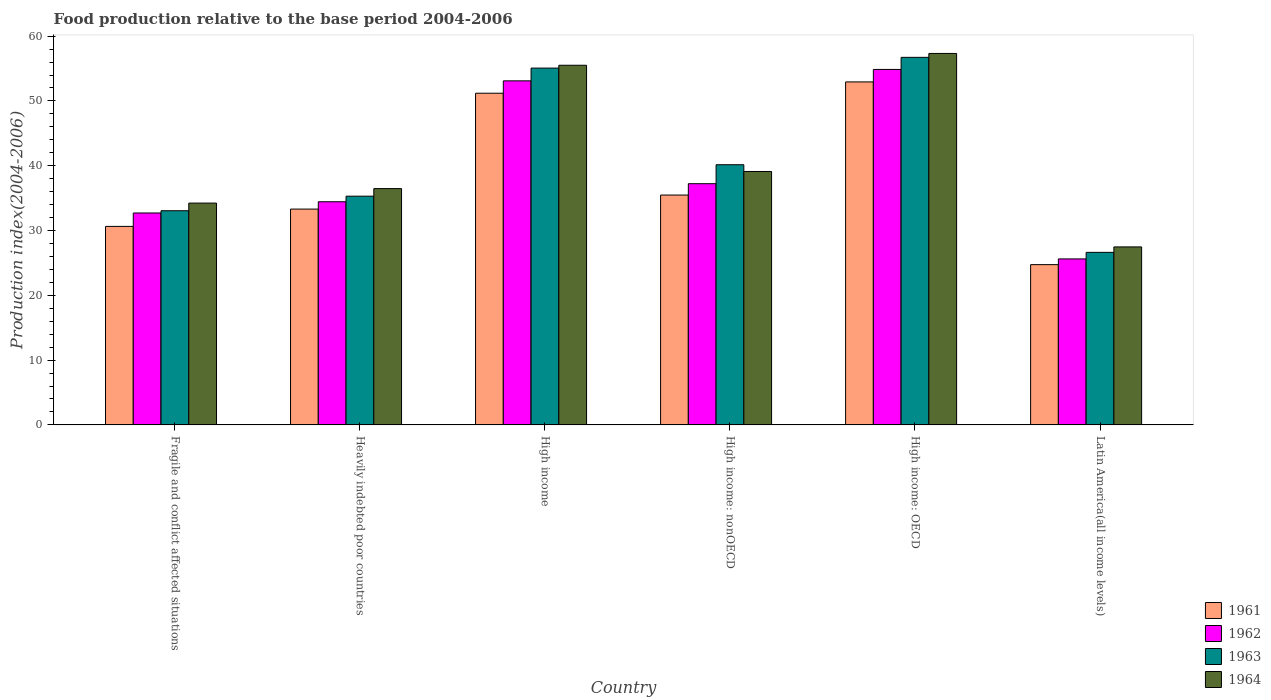How many different coloured bars are there?
Ensure brevity in your answer.  4. How many groups of bars are there?
Your response must be concise. 6. Are the number of bars per tick equal to the number of legend labels?
Provide a short and direct response. Yes. How many bars are there on the 4th tick from the left?
Your response must be concise. 4. What is the label of the 1st group of bars from the left?
Your answer should be very brief. Fragile and conflict affected situations. What is the food production index in 1961 in High income?
Your answer should be very brief. 51.19. Across all countries, what is the maximum food production index in 1961?
Provide a short and direct response. 52.93. Across all countries, what is the minimum food production index in 1963?
Make the answer very short. 26.63. In which country was the food production index in 1964 maximum?
Your answer should be compact. High income: OECD. In which country was the food production index in 1962 minimum?
Provide a short and direct response. Latin America(all income levels). What is the total food production index in 1964 in the graph?
Ensure brevity in your answer.  250.12. What is the difference between the food production index in 1964 in Heavily indebted poor countries and that in High income: nonOECD?
Your answer should be compact. -2.64. What is the difference between the food production index in 1962 in Latin America(all income levels) and the food production index in 1964 in High income?
Your response must be concise. -29.89. What is the average food production index in 1964 per country?
Keep it short and to the point. 41.69. What is the difference between the food production index of/in 1962 and food production index of/in 1963 in Heavily indebted poor countries?
Give a very brief answer. -0.86. What is the ratio of the food production index in 1964 in High income to that in High income: nonOECD?
Make the answer very short. 1.42. Is the food production index in 1961 in Heavily indebted poor countries less than that in Latin America(all income levels)?
Your answer should be compact. No. Is the difference between the food production index in 1962 in Fragile and conflict affected situations and Latin America(all income levels) greater than the difference between the food production index in 1963 in Fragile and conflict affected situations and Latin America(all income levels)?
Your response must be concise. Yes. What is the difference between the highest and the second highest food production index in 1963?
Give a very brief answer. 16.57. What is the difference between the highest and the lowest food production index in 1963?
Provide a succinct answer. 30.1. What does the 4th bar from the left in Latin America(all income levels) represents?
Offer a very short reply. 1964. What does the 3rd bar from the right in High income: nonOECD represents?
Your response must be concise. 1962. Is it the case that in every country, the sum of the food production index in 1962 and food production index in 1961 is greater than the food production index in 1964?
Your answer should be compact. Yes. How many bars are there?
Keep it short and to the point. 24. How many countries are there in the graph?
Provide a succinct answer. 6. Are the values on the major ticks of Y-axis written in scientific E-notation?
Make the answer very short. No. Does the graph contain any zero values?
Your answer should be very brief. No. Does the graph contain grids?
Provide a short and direct response. No. How many legend labels are there?
Provide a short and direct response. 4. What is the title of the graph?
Your answer should be compact. Food production relative to the base period 2004-2006. Does "1993" appear as one of the legend labels in the graph?
Your answer should be compact. No. What is the label or title of the X-axis?
Ensure brevity in your answer.  Country. What is the label or title of the Y-axis?
Offer a terse response. Production index(2004-2006). What is the Production index(2004-2006) in 1961 in Fragile and conflict affected situations?
Offer a terse response. 30.64. What is the Production index(2004-2006) of 1962 in Fragile and conflict affected situations?
Offer a terse response. 32.71. What is the Production index(2004-2006) in 1963 in Fragile and conflict affected situations?
Give a very brief answer. 33.05. What is the Production index(2004-2006) of 1964 in Fragile and conflict affected situations?
Make the answer very short. 34.23. What is the Production index(2004-2006) of 1961 in Heavily indebted poor countries?
Your answer should be very brief. 33.31. What is the Production index(2004-2006) of 1962 in Heavily indebted poor countries?
Provide a short and direct response. 34.44. What is the Production index(2004-2006) in 1963 in Heavily indebted poor countries?
Provide a succinct answer. 35.3. What is the Production index(2004-2006) of 1964 in Heavily indebted poor countries?
Your answer should be compact. 36.47. What is the Production index(2004-2006) of 1961 in High income?
Ensure brevity in your answer.  51.19. What is the Production index(2004-2006) of 1962 in High income?
Make the answer very short. 53.1. What is the Production index(2004-2006) in 1963 in High income?
Offer a terse response. 55.07. What is the Production index(2004-2006) of 1964 in High income?
Provide a short and direct response. 55.51. What is the Production index(2004-2006) of 1961 in High income: nonOECD?
Provide a short and direct response. 35.48. What is the Production index(2004-2006) in 1962 in High income: nonOECD?
Provide a succinct answer. 37.23. What is the Production index(2004-2006) of 1963 in High income: nonOECD?
Your answer should be compact. 40.16. What is the Production index(2004-2006) in 1964 in High income: nonOECD?
Give a very brief answer. 39.11. What is the Production index(2004-2006) of 1961 in High income: OECD?
Provide a short and direct response. 52.93. What is the Production index(2004-2006) in 1962 in High income: OECD?
Keep it short and to the point. 54.86. What is the Production index(2004-2006) of 1963 in High income: OECD?
Provide a succinct answer. 56.73. What is the Production index(2004-2006) of 1964 in High income: OECD?
Your answer should be very brief. 57.33. What is the Production index(2004-2006) in 1961 in Latin America(all income levels)?
Keep it short and to the point. 24.74. What is the Production index(2004-2006) in 1962 in Latin America(all income levels)?
Offer a terse response. 25.62. What is the Production index(2004-2006) of 1963 in Latin America(all income levels)?
Make the answer very short. 26.63. What is the Production index(2004-2006) of 1964 in Latin America(all income levels)?
Provide a succinct answer. 27.47. Across all countries, what is the maximum Production index(2004-2006) in 1961?
Your response must be concise. 52.93. Across all countries, what is the maximum Production index(2004-2006) of 1962?
Make the answer very short. 54.86. Across all countries, what is the maximum Production index(2004-2006) of 1963?
Give a very brief answer. 56.73. Across all countries, what is the maximum Production index(2004-2006) in 1964?
Offer a terse response. 57.33. Across all countries, what is the minimum Production index(2004-2006) in 1961?
Provide a succinct answer. 24.74. Across all countries, what is the minimum Production index(2004-2006) in 1962?
Your answer should be very brief. 25.62. Across all countries, what is the minimum Production index(2004-2006) in 1963?
Your answer should be compact. 26.63. Across all countries, what is the minimum Production index(2004-2006) of 1964?
Provide a succinct answer. 27.47. What is the total Production index(2004-2006) of 1961 in the graph?
Offer a very short reply. 228.28. What is the total Production index(2004-2006) of 1962 in the graph?
Offer a very short reply. 237.96. What is the total Production index(2004-2006) in 1963 in the graph?
Your answer should be very brief. 246.93. What is the total Production index(2004-2006) in 1964 in the graph?
Ensure brevity in your answer.  250.12. What is the difference between the Production index(2004-2006) of 1961 in Fragile and conflict affected situations and that in Heavily indebted poor countries?
Your answer should be very brief. -2.67. What is the difference between the Production index(2004-2006) in 1962 in Fragile and conflict affected situations and that in Heavily indebted poor countries?
Make the answer very short. -1.74. What is the difference between the Production index(2004-2006) in 1963 in Fragile and conflict affected situations and that in Heavily indebted poor countries?
Keep it short and to the point. -2.25. What is the difference between the Production index(2004-2006) in 1964 in Fragile and conflict affected situations and that in Heavily indebted poor countries?
Your answer should be compact. -2.24. What is the difference between the Production index(2004-2006) in 1961 in Fragile and conflict affected situations and that in High income?
Give a very brief answer. -20.55. What is the difference between the Production index(2004-2006) in 1962 in Fragile and conflict affected situations and that in High income?
Keep it short and to the point. -20.39. What is the difference between the Production index(2004-2006) of 1963 in Fragile and conflict affected situations and that in High income?
Keep it short and to the point. -22.02. What is the difference between the Production index(2004-2006) in 1964 in Fragile and conflict affected situations and that in High income?
Your answer should be very brief. -21.27. What is the difference between the Production index(2004-2006) of 1961 in Fragile and conflict affected situations and that in High income: nonOECD?
Provide a succinct answer. -4.84. What is the difference between the Production index(2004-2006) in 1962 in Fragile and conflict affected situations and that in High income: nonOECD?
Keep it short and to the point. -4.52. What is the difference between the Production index(2004-2006) in 1963 in Fragile and conflict affected situations and that in High income: nonOECD?
Provide a short and direct response. -7.1. What is the difference between the Production index(2004-2006) of 1964 in Fragile and conflict affected situations and that in High income: nonOECD?
Offer a very short reply. -4.88. What is the difference between the Production index(2004-2006) of 1961 in Fragile and conflict affected situations and that in High income: OECD?
Your response must be concise. -22.3. What is the difference between the Production index(2004-2006) in 1962 in Fragile and conflict affected situations and that in High income: OECD?
Provide a succinct answer. -22.16. What is the difference between the Production index(2004-2006) of 1963 in Fragile and conflict affected situations and that in High income: OECD?
Make the answer very short. -23.67. What is the difference between the Production index(2004-2006) of 1964 in Fragile and conflict affected situations and that in High income: OECD?
Offer a very short reply. -23.09. What is the difference between the Production index(2004-2006) of 1961 in Fragile and conflict affected situations and that in Latin America(all income levels)?
Your response must be concise. 5.9. What is the difference between the Production index(2004-2006) in 1962 in Fragile and conflict affected situations and that in Latin America(all income levels)?
Your answer should be compact. 7.09. What is the difference between the Production index(2004-2006) in 1963 in Fragile and conflict affected situations and that in Latin America(all income levels)?
Make the answer very short. 6.42. What is the difference between the Production index(2004-2006) in 1964 in Fragile and conflict affected situations and that in Latin America(all income levels)?
Provide a short and direct response. 6.76. What is the difference between the Production index(2004-2006) in 1961 in Heavily indebted poor countries and that in High income?
Offer a terse response. -17.88. What is the difference between the Production index(2004-2006) in 1962 in Heavily indebted poor countries and that in High income?
Ensure brevity in your answer.  -18.66. What is the difference between the Production index(2004-2006) of 1963 in Heavily indebted poor countries and that in High income?
Provide a short and direct response. -19.77. What is the difference between the Production index(2004-2006) of 1964 in Heavily indebted poor countries and that in High income?
Your answer should be compact. -19.04. What is the difference between the Production index(2004-2006) in 1961 in Heavily indebted poor countries and that in High income: nonOECD?
Your response must be concise. -2.17. What is the difference between the Production index(2004-2006) of 1962 in Heavily indebted poor countries and that in High income: nonOECD?
Keep it short and to the point. -2.78. What is the difference between the Production index(2004-2006) in 1963 in Heavily indebted poor countries and that in High income: nonOECD?
Your answer should be compact. -4.86. What is the difference between the Production index(2004-2006) of 1964 in Heavily indebted poor countries and that in High income: nonOECD?
Make the answer very short. -2.64. What is the difference between the Production index(2004-2006) of 1961 in Heavily indebted poor countries and that in High income: OECD?
Your response must be concise. -19.63. What is the difference between the Production index(2004-2006) of 1962 in Heavily indebted poor countries and that in High income: OECD?
Your answer should be very brief. -20.42. What is the difference between the Production index(2004-2006) in 1963 in Heavily indebted poor countries and that in High income: OECD?
Your response must be concise. -21.43. What is the difference between the Production index(2004-2006) of 1964 in Heavily indebted poor countries and that in High income: OECD?
Offer a very short reply. -20.86. What is the difference between the Production index(2004-2006) in 1961 in Heavily indebted poor countries and that in Latin America(all income levels)?
Make the answer very short. 8.57. What is the difference between the Production index(2004-2006) in 1962 in Heavily indebted poor countries and that in Latin America(all income levels)?
Offer a terse response. 8.82. What is the difference between the Production index(2004-2006) of 1963 in Heavily indebted poor countries and that in Latin America(all income levels)?
Provide a short and direct response. 8.67. What is the difference between the Production index(2004-2006) of 1964 in Heavily indebted poor countries and that in Latin America(all income levels)?
Your answer should be very brief. 9. What is the difference between the Production index(2004-2006) of 1961 in High income and that in High income: nonOECD?
Your response must be concise. 15.71. What is the difference between the Production index(2004-2006) in 1962 in High income and that in High income: nonOECD?
Keep it short and to the point. 15.87. What is the difference between the Production index(2004-2006) in 1963 in High income and that in High income: nonOECD?
Make the answer very short. 14.91. What is the difference between the Production index(2004-2006) in 1964 in High income and that in High income: nonOECD?
Provide a short and direct response. 16.39. What is the difference between the Production index(2004-2006) in 1961 in High income and that in High income: OECD?
Make the answer very short. -1.75. What is the difference between the Production index(2004-2006) in 1962 in High income and that in High income: OECD?
Ensure brevity in your answer.  -1.76. What is the difference between the Production index(2004-2006) in 1963 in High income and that in High income: OECD?
Provide a short and direct response. -1.66. What is the difference between the Production index(2004-2006) in 1964 in High income and that in High income: OECD?
Your answer should be very brief. -1.82. What is the difference between the Production index(2004-2006) in 1961 in High income and that in Latin America(all income levels)?
Offer a very short reply. 26.45. What is the difference between the Production index(2004-2006) in 1962 in High income and that in Latin America(all income levels)?
Your answer should be very brief. 27.48. What is the difference between the Production index(2004-2006) of 1963 in High income and that in Latin America(all income levels)?
Provide a succinct answer. 28.44. What is the difference between the Production index(2004-2006) of 1964 in High income and that in Latin America(all income levels)?
Your answer should be very brief. 28.04. What is the difference between the Production index(2004-2006) of 1961 in High income: nonOECD and that in High income: OECD?
Give a very brief answer. -17.46. What is the difference between the Production index(2004-2006) of 1962 in High income: nonOECD and that in High income: OECD?
Offer a terse response. -17.64. What is the difference between the Production index(2004-2006) in 1963 in High income: nonOECD and that in High income: OECD?
Offer a very short reply. -16.57. What is the difference between the Production index(2004-2006) of 1964 in High income: nonOECD and that in High income: OECD?
Offer a very short reply. -18.22. What is the difference between the Production index(2004-2006) of 1961 in High income: nonOECD and that in Latin America(all income levels)?
Keep it short and to the point. 10.74. What is the difference between the Production index(2004-2006) in 1962 in High income: nonOECD and that in Latin America(all income levels)?
Provide a succinct answer. 11.61. What is the difference between the Production index(2004-2006) in 1963 in High income: nonOECD and that in Latin America(all income levels)?
Your response must be concise. 13.53. What is the difference between the Production index(2004-2006) of 1964 in High income: nonOECD and that in Latin America(all income levels)?
Make the answer very short. 11.64. What is the difference between the Production index(2004-2006) of 1961 in High income: OECD and that in Latin America(all income levels)?
Your response must be concise. 28.2. What is the difference between the Production index(2004-2006) of 1962 in High income: OECD and that in Latin America(all income levels)?
Ensure brevity in your answer.  29.24. What is the difference between the Production index(2004-2006) of 1963 in High income: OECD and that in Latin America(all income levels)?
Your answer should be very brief. 30.1. What is the difference between the Production index(2004-2006) of 1964 in High income: OECD and that in Latin America(all income levels)?
Provide a succinct answer. 29.86. What is the difference between the Production index(2004-2006) of 1961 in Fragile and conflict affected situations and the Production index(2004-2006) of 1962 in Heavily indebted poor countries?
Your answer should be very brief. -3.81. What is the difference between the Production index(2004-2006) of 1961 in Fragile and conflict affected situations and the Production index(2004-2006) of 1963 in Heavily indebted poor countries?
Make the answer very short. -4.66. What is the difference between the Production index(2004-2006) in 1961 in Fragile and conflict affected situations and the Production index(2004-2006) in 1964 in Heavily indebted poor countries?
Offer a very short reply. -5.83. What is the difference between the Production index(2004-2006) of 1962 in Fragile and conflict affected situations and the Production index(2004-2006) of 1963 in Heavily indebted poor countries?
Offer a very short reply. -2.59. What is the difference between the Production index(2004-2006) in 1962 in Fragile and conflict affected situations and the Production index(2004-2006) in 1964 in Heavily indebted poor countries?
Your response must be concise. -3.76. What is the difference between the Production index(2004-2006) of 1963 in Fragile and conflict affected situations and the Production index(2004-2006) of 1964 in Heavily indebted poor countries?
Give a very brief answer. -3.42. What is the difference between the Production index(2004-2006) of 1961 in Fragile and conflict affected situations and the Production index(2004-2006) of 1962 in High income?
Provide a short and direct response. -22.46. What is the difference between the Production index(2004-2006) of 1961 in Fragile and conflict affected situations and the Production index(2004-2006) of 1963 in High income?
Ensure brevity in your answer.  -24.43. What is the difference between the Production index(2004-2006) in 1961 in Fragile and conflict affected situations and the Production index(2004-2006) in 1964 in High income?
Your answer should be compact. -24.87. What is the difference between the Production index(2004-2006) in 1962 in Fragile and conflict affected situations and the Production index(2004-2006) in 1963 in High income?
Ensure brevity in your answer.  -22.36. What is the difference between the Production index(2004-2006) in 1962 in Fragile and conflict affected situations and the Production index(2004-2006) in 1964 in High income?
Your answer should be very brief. -22.8. What is the difference between the Production index(2004-2006) of 1963 in Fragile and conflict affected situations and the Production index(2004-2006) of 1964 in High income?
Provide a short and direct response. -22.45. What is the difference between the Production index(2004-2006) of 1961 in Fragile and conflict affected situations and the Production index(2004-2006) of 1962 in High income: nonOECD?
Ensure brevity in your answer.  -6.59. What is the difference between the Production index(2004-2006) in 1961 in Fragile and conflict affected situations and the Production index(2004-2006) in 1963 in High income: nonOECD?
Provide a short and direct response. -9.52. What is the difference between the Production index(2004-2006) in 1961 in Fragile and conflict affected situations and the Production index(2004-2006) in 1964 in High income: nonOECD?
Offer a very short reply. -8.47. What is the difference between the Production index(2004-2006) of 1962 in Fragile and conflict affected situations and the Production index(2004-2006) of 1963 in High income: nonOECD?
Provide a short and direct response. -7.45. What is the difference between the Production index(2004-2006) of 1962 in Fragile and conflict affected situations and the Production index(2004-2006) of 1964 in High income: nonOECD?
Offer a terse response. -6.4. What is the difference between the Production index(2004-2006) of 1963 in Fragile and conflict affected situations and the Production index(2004-2006) of 1964 in High income: nonOECD?
Offer a terse response. -6.06. What is the difference between the Production index(2004-2006) in 1961 in Fragile and conflict affected situations and the Production index(2004-2006) in 1962 in High income: OECD?
Your answer should be compact. -24.23. What is the difference between the Production index(2004-2006) in 1961 in Fragile and conflict affected situations and the Production index(2004-2006) in 1963 in High income: OECD?
Make the answer very short. -26.09. What is the difference between the Production index(2004-2006) in 1961 in Fragile and conflict affected situations and the Production index(2004-2006) in 1964 in High income: OECD?
Your response must be concise. -26.69. What is the difference between the Production index(2004-2006) in 1962 in Fragile and conflict affected situations and the Production index(2004-2006) in 1963 in High income: OECD?
Your answer should be very brief. -24.02. What is the difference between the Production index(2004-2006) in 1962 in Fragile and conflict affected situations and the Production index(2004-2006) in 1964 in High income: OECD?
Provide a short and direct response. -24.62. What is the difference between the Production index(2004-2006) in 1963 in Fragile and conflict affected situations and the Production index(2004-2006) in 1964 in High income: OECD?
Ensure brevity in your answer.  -24.28. What is the difference between the Production index(2004-2006) of 1961 in Fragile and conflict affected situations and the Production index(2004-2006) of 1962 in Latin America(all income levels)?
Ensure brevity in your answer.  5.02. What is the difference between the Production index(2004-2006) in 1961 in Fragile and conflict affected situations and the Production index(2004-2006) in 1963 in Latin America(all income levels)?
Keep it short and to the point. 4.01. What is the difference between the Production index(2004-2006) of 1961 in Fragile and conflict affected situations and the Production index(2004-2006) of 1964 in Latin America(all income levels)?
Keep it short and to the point. 3.17. What is the difference between the Production index(2004-2006) in 1962 in Fragile and conflict affected situations and the Production index(2004-2006) in 1963 in Latin America(all income levels)?
Your answer should be very brief. 6.08. What is the difference between the Production index(2004-2006) in 1962 in Fragile and conflict affected situations and the Production index(2004-2006) in 1964 in Latin America(all income levels)?
Offer a very short reply. 5.24. What is the difference between the Production index(2004-2006) of 1963 in Fragile and conflict affected situations and the Production index(2004-2006) of 1964 in Latin America(all income levels)?
Provide a succinct answer. 5.58. What is the difference between the Production index(2004-2006) of 1961 in Heavily indebted poor countries and the Production index(2004-2006) of 1962 in High income?
Offer a very short reply. -19.79. What is the difference between the Production index(2004-2006) in 1961 in Heavily indebted poor countries and the Production index(2004-2006) in 1963 in High income?
Provide a short and direct response. -21.76. What is the difference between the Production index(2004-2006) in 1961 in Heavily indebted poor countries and the Production index(2004-2006) in 1964 in High income?
Your answer should be very brief. -22.2. What is the difference between the Production index(2004-2006) in 1962 in Heavily indebted poor countries and the Production index(2004-2006) in 1963 in High income?
Your response must be concise. -20.62. What is the difference between the Production index(2004-2006) of 1962 in Heavily indebted poor countries and the Production index(2004-2006) of 1964 in High income?
Provide a short and direct response. -21.06. What is the difference between the Production index(2004-2006) of 1963 in Heavily indebted poor countries and the Production index(2004-2006) of 1964 in High income?
Ensure brevity in your answer.  -20.21. What is the difference between the Production index(2004-2006) of 1961 in Heavily indebted poor countries and the Production index(2004-2006) of 1962 in High income: nonOECD?
Provide a short and direct response. -3.92. What is the difference between the Production index(2004-2006) in 1961 in Heavily indebted poor countries and the Production index(2004-2006) in 1963 in High income: nonOECD?
Offer a terse response. -6.85. What is the difference between the Production index(2004-2006) in 1961 in Heavily indebted poor countries and the Production index(2004-2006) in 1964 in High income: nonOECD?
Offer a very short reply. -5.8. What is the difference between the Production index(2004-2006) of 1962 in Heavily indebted poor countries and the Production index(2004-2006) of 1963 in High income: nonOECD?
Provide a succinct answer. -5.71. What is the difference between the Production index(2004-2006) of 1962 in Heavily indebted poor countries and the Production index(2004-2006) of 1964 in High income: nonOECD?
Offer a terse response. -4.67. What is the difference between the Production index(2004-2006) in 1963 in Heavily indebted poor countries and the Production index(2004-2006) in 1964 in High income: nonOECD?
Provide a succinct answer. -3.81. What is the difference between the Production index(2004-2006) of 1961 in Heavily indebted poor countries and the Production index(2004-2006) of 1962 in High income: OECD?
Offer a very short reply. -21.56. What is the difference between the Production index(2004-2006) in 1961 in Heavily indebted poor countries and the Production index(2004-2006) in 1963 in High income: OECD?
Your answer should be very brief. -23.42. What is the difference between the Production index(2004-2006) in 1961 in Heavily indebted poor countries and the Production index(2004-2006) in 1964 in High income: OECD?
Ensure brevity in your answer.  -24.02. What is the difference between the Production index(2004-2006) of 1962 in Heavily indebted poor countries and the Production index(2004-2006) of 1963 in High income: OECD?
Offer a very short reply. -22.28. What is the difference between the Production index(2004-2006) of 1962 in Heavily indebted poor countries and the Production index(2004-2006) of 1964 in High income: OECD?
Offer a terse response. -22.89. What is the difference between the Production index(2004-2006) in 1963 in Heavily indebted poor countries and the Production index(2004-2006) in 1964 in High income: OECD?
Keep it short and to the point. -22.03. What is the difference between the Production index(2004-2006) in 1961 in Heavily indebted poor countries and the Production index(2004-2006) in 1962 in Latin America(all income levels)?
Provide a short and direct response. 7.69. What is the difference between the Production index(2004-2006) in 1961 in Heavily indebted poor countries and the Production index(2004-2006) in 1963 in Latin America(all income levels)?
Make the answer very short. 6.68. What is the difference between the Production index(2004-2006) in 1961 in Heavily indebted poor countries and the Production index(2004-2006) in 1964 in Latin America(all income levels)?
Ensure brevity in your answer.  5.84. What is the difference between the Production index(2004-2006) of 1962 in Heavily indebted poor countries and the Production index(2004-2006) of 1963 in Latin America(all income levels)?
Keep it short and to the point. 7.81. What is the difference between the Production index(2004-2006) of 1962 in Heavily indebted poor countries and the Production index(2004-2006) of 1964 in Latin America(all income levels)?
Keep it short and to the point. 6.97. What is the difference between the Production index(2004-2006) in 1963 in Heavily indebted poor countries and the Production index(2004-2006) in 1964 in Latin America(all income levels)?
Keep it short and to the point. 7.83. What is the difference between the Production index(2004-2006) in 1961 in High income and the Production index(2004-2006) in 1962 in High income: nonOECD?
Provide a short and direct response. 13.96. What is the difference between the Production index(2004-2006) in 1961 in High income and the Production index(2004-2006) in 1963 in High income: nonOECD?
Provide a short and direct response. 11.03. What is the difference between the Production index(2004-2006) of 1961 in High income and the Production index(2004-2006) of 1964 in High income: nonOECD?
Give a very brief answer. 12.08. What is the difference between the Production index(2004-2006) of 1962 in High income and the Production index(2004-2006) of 1963 in High income: nonOECD?
Provide a succinct answer. 12.94. What is the difference between the Production index(2004-2006) of 1962 in High income and the Production index(2004-2006) of 1964 in High income: nonOECD?
Provide a succinct answer. 13.99. What is the difference between the Production index(2004-2006) in 1963 in High income and the Production index(2004-2006) in 1964 in High income: nonOECD?
Make the answer very short. 15.96. What is the difference between the Production index(2004-2006) of 1961 in High income and the Production index(2004-2006) of 1962 in High income: OECD?
Make the answer very short. -3.67. What is the difference between the Production index(2004-2006) in 1961 in High income and the Production index(2004-2006) in 1963 in High income: OECD?
Give a very brief answer. -5.54. What is the difference between the Production index(2004-2006) in 1961 in High income and the Production index(2004-2006) in 1964 in High income: OECD?
Your answer should be compact. -6.14. What is the difference between the Production index(2004-2006) in 1962 in High income and the Production index(2004-2006) in 1963 in High income: OECD?
Keep it short and to the point. -3.63. What is the difference between the Production index(2004-2006) of 1962 in High income and the Production index(2004-2006) of 1964 in High income: OECD?
Keep it short and to the point. -4.23. What is the difference between the Production index(2004-2006) in 1963 in High income and the Production index(2004-2006) in 1964 in High income: OECD?
Ensure brevity in your answer.  -2.26. What is the difference between the Production index(2004-2006) of 1961 in High income and the Production index(2004-2006) of 1962 in Latin America(all income levels)?
Ensure brevity in your answer.  25.57. What is the difference between the Production index(2004-2006) in 1961 in High income and the Production index(2004-2006) in 1963 in Latin America(all income levels)?
Offer a very short reply. 24.56. What is the difference between the Production index(2004-2006) of 1961 in High income and the Production index(2004-2006) of 1964 in Latin America(all income levels)?
Offer a terse response. 23.72. What is the difference between the Production index(2004-2006) in 1962 in High income and the Production index(2004-2006) in 1963 in Latin America(all income levels)?
Your answer should be very brief. 26.47. What is the difference between the Production index(2004-2006) in 1962 in High income and the Production index(2004-2006) in 1964 in Latin America(all income levels)?
Give a very brief answer. 25.63. What is the difference between the Production index(2004-2006) in 1963 in High income and the Production index(2004-2006) in 1964 in Latin America(all income levels)?
Provide a short and direct response. 27.6. What is the difference between the Production index(2004-2006) in 1961 in High income: nonOECD and the Production index(2004-2006) in 1962 in High income: OECD?
Make the answer very short. -19.39. What is the difference between the Production index(2004-2006) of 1961 in High income: nonOECD and the Production index(2004-2006) of 1963 in High income: OECD?
Offer a very short reply. -21.25. What is the difference between the Production index(2004-2006) in 1961 in High income: nonOECD and the Production index(2004-2006) in 1964 in High income: OECD?
Offer a very short reply. -21.85. What is the difference between the Production index(2004-2006) in 1962 in High income: nonOECD and the Production index(2004-2006) in 1963 in High income: OECD?
Your response must be concise. -19.5. What is the difference between the Production index(2004-2006) of 1962 in High income: nonOECD and the Production index(2004-2006) of 1964 in High income: OECD?
Your answer should be compact. -20.1. What is the difference between the Production index(2004-2006) in 1963 in High income: nonOECD and the Production index(2004-2006) in 1964 in High income: OECD?
Provide a short and direct response. -17.17. What is the difference between the Production index(2004-2006) in 1961 in High income: nonOECD and the Production index(2004-2006) in 1962 in Latin America(all income levels)?
Provide a short and direct response. 9.86. What is the difference between the Production index(2004-2006) of 1961 in High income: nonOECD and the Production index(2004-2006) of 1963 in Latin America(all income levels)?
Ensure brevity in your answer.  8.85. What is the difference between the Production index(2004-2006) of 1961 in High income: nonOECD and the Production index(2004-2006) of 1964 in Latin America(all income levels)?
Your response must be concise. 8. What is the difference between the Production index(2004-2006) in 1962 in High income: nonOECD and the Production index(2004-2006) in 1963 in Latin America(all income levels)?
Your answer should be compact. 10.6. What is the difference between the Production index(2004-2006) of 1962 in High income: nonOECD and the Production index(2004-2006) of 1964 in Latin America(all income levels)?
Provide a succinct answer. 9.76. What is the difference between the Production index(2004-2006) in 1963 in High income: nonOECD and the Production index(2004-2006) in 1964 in Latin America(all income levels)?
Offer a terse response. 12.68. What is the difference between the Production index(2004-2006) of 1961 in High income: OECD and the Production index(2004-2006) of 1962 in Latin America(all income levels)?
Ensure brevity in your answer.  27.31. What is the difference between the Production index(2004-2006) in 1961 in High income: OECD and the Production index(2004-2006) in 1963 in Latin America(all income levels)?
Ensure brevity in your answer.  26.3. What is the difference between the Production index(2004-2006) in 1961 in High income: OECD and the Production index(2004-2006) in 1964 in Latin America(all income levels)?
Keep it short and to the point. 25.46. What is the difference between the Production index(2004-2006) of 1962 in High income: OECD and the Production index(2004-2006) of 1963 in Latin America(all income levels)?
Make the answer very short. 28.23. What is the difference between the Production index(2004-2006) of 1962 in High income: OECD and the Production index(2004-2006) of 1964 in Latin America(all income levels)?
Offer a very short reply. 27.39. What is the difference between the Production index(2004-2006) in 1963 in High income: OECD and the Production index(2004-2006) in 1964 in Latin America(all income levels)?
Provide a short and direct response. 29.25. What is the average Production index(2004-2006) in 1961 per country?
Provide a short and direct response. 38.05. What is the average Production index(2004-2006) in 1962 per country?
Ensure brevity in your answer.  39.66. What is the average Production index(2004-2006) in 1963 per country?
Offer a very short reply. 41.16. What is the average Production index(2004-2006) in 1964 per country?
Your answer should be compact. 41.69. What is the difference between the Production index(2004-2006) of 1961 and Production index(2004-2006) of 1962 in Fragile and conflict affected situations?
Provide a succinct answer. -2.07. What is the difference between the Production index(2004-2006) of 1961 and Production index(2004-2006) of 1963 in Fragile and conflict affected situations?
Provide a succinct answer. -2.42. What is the difference between the Production index(2004-2006) in 1961 and Production index(2004-2006) in 1964 in Fragile and conflict affected situations?
Give a very brief answer. -3.6. What is the difference between the Production index(2004-2006) of 1962 and Production index(2004-2006) of 1963 in Fragile and conflict affected situations?
Provide a succinct answer. -0.35. What is the difference between the Production index(2004-2006) in 1962 and Production index(2004-2006) in 1964 in Fragile and conflict affected situations?
Provide a short and direct response. -1.53. What is the difference between the Production index(2004-2006) of 1963 and Production index(2004-2006) of 1964 in Fragile and conflict affected situations?
Your answer should be very brief. -1.18. What is the difference between the Production index(2004-2006) in 1961 and Production index(2004-2006) in 1962 in Heavily indebted poor countries?
Give a very brief answer. -1.14. What is the difference between the Production index(2004-2006) of 1961 and Production index(2004-2006) of 1963 in Heavily indebted poor countries?
Provide a succinct answer. -1.99. What is the difference between the Production index(2004-2006) of 1961 and Production index(2004-2006) of 1964 in Heavily indebted poor countries?
Make the answer very short. -3.16. What is the difference between the Production index(2004-2006) in 1962 and Production index(2004-2006) in 1963 in Heavily indebted poor countries?
Offer a terse response. -0.86. What is the difference between the Production index(2004-2006) in 1962 and Production index(2004-2006) in 1964 in Heavily indebted poor countries?
Make the answer very short. -2.03. What is the difference between the Production index(2004-2006) in 1963 and Production index(2004-2006) in 1964 in Heavily indebted poor countries?
Ensure brevity in your answer.  -1.17. What is the difference between the Production index(2004-2006) in 1961 and Production index(2004-2006) in 1962 in High income?
Keep it short and to the point. -1.91. What is the difference between the Production index(2004-2006) of 1961 and Production index(2004-2006) of 1963 in High income?
Provide a short and direct response. -3.88. What is the difference between the Production index(2004-2006) of 1961 and Production index(2004-2006) of 1964 in High income?
Your answer should be very brief. -4.32. What is the difference between the Production index(2004-2006) in 1962 and Production index(2004-2006) in 1963 in High income?
Give a very brief answer. -1.97. What is the difference between the Production index(2004-2006) in 1962 and Production index(2004-2006) in 1964 in High income?
Provide a succinct answer. -2.41. What is the difference between the Production index(2004-2006) in 1963 and Production index(2004-2006) in 1964 in High income?
Keep it short and to the point. -0.44. What is the difference between the Production index(2004-2006) in 1961 and Production index(2004-2006) in 1962 in High income: nonOECD?
Provide a short and direct response. -1.75. What is the difference between the Production index(2004-2006) of 1961 and Production index(2004-2006) of 1963 in High income: nonOECD?
Your answer should be very brief. -4.68. What is the difference between the Production index(2004-2006) in 1961 and Production index(2004-2006) in 1964 in High income: nonOECD?
Make the answer very short. -3.64. What is the difference between the Production index(2004-2006) in 1962 and Production index(2004-2006) in 1963 in High income: nonOECD?
Your answer should be compact. -2.93. What is the difference between the Production index(2004-2006) in 1962 and Production index(2004-2006) in 1964 in High income: nonOECD?
Your answer should be very brief. -1.88. What is the difference between the Production index(2004-2006) of 1963 and Production index(2004-2006) of 1964 in High income: nonOECD?
Ensure brevity in your answer.  1.04. What is the difference between the Production index(2004-2006) in 1961 and Production index(2004-2006) in 1962 in High income: OECD?
Provide a short and direct response. -1.93. What is the difference between the Production index(2004-2006) of 1961 and Production index(2004-2006) of 1963 in High income: OECD?
Your answer should be very brief. -3.79. What is the difference between the Production index(2004-2006) of 1961 and Production index(2004-2006) of 1964 in High income: OECD?
Give a very brief answer. -4.39. What is the difference between the Production index(2004-2006) of 1962 and Production index(2004-2006) of 1963 in High income: OECD?
Keep it short and to the point. -1.86. What is the difference between the Production index(2004-2006) in 1962 and Production index(2004-2006) in 1964 in High income: OECD?
Offer a very short reply. -2.47. What is the difference between the Production index(2004-2006) in 1963 and Production index(2004-2006) in 1964 in High income: OECD?
Offer a very short reply. -0.6. What is the difference between the Production index(2004-2006) of 1961 and Production index(2004-2006) of 1962 in Latin America(all income levels)?
Offer a terse response. -0.88. What is the difference between the Production index(2004-2006) of 1961 and Production index(2004-2006) of 1963 in Latin America(all income levels)?
Your response must be concise. -1.89. What is the difference between the Production index(2004-2006) of 1961 and Production index(2004-2006) of 1964 in Latin America(all income levels)?
Ensure brevity in your answer.  -2.74. What is the difference between the Production index(2004-2006) in 1962 and Production index(2004-2006) in 1963 in Latin America(all income levels)?
Provide a short and direct response. -1.01. What is the difference between the Production index(2004-2006) of 1962 and Production index(2004-2006) of 1964 in Latin America(all income levels)?
Keep it short and to the point. -1.85. What is the difference between the Production index(2004-2006) of 1963 and Production index(2004-2006) of 1964 in Latin America(all income levels)?
Your answer should be very brief. -0.84. What is the ratio of the Production index(2004-2006) of 1961 in Fragile and conflict affected situations to that in Heavily indebted poor countries?
Your answer should be very brief. 0.92. What is the ratio of the Production index(2004-2006) in 1962 in Fragile and conflict affected situations to that in Heavily indebted poor countries?
Your answer should be very brief. 0.95. What is the ratio of the Production index(2004-2006) of 1963 in Fragile and conflict affected situations to that in Heavily indebted poor countries?
Give a very brief answer. 0.94. What is the ratio of the Production index(2004-2006) of 1964 in Fragile and conflict affected situations to that in Heavily indebted poor countries?
Ensure brevity in your answer.  0.94. What is the ratio of the Production index(2004-2006) in 1961 in Fragile and conflict affected situations to that in High income?
Keep it short and to the point. 0.6. What is the ratio of the Production index(2004-2006) of 1962 in Fragile and conflict affected situations to that in High income?
Your answer should be very brief. 0.62. What is the ratio of the Production index(2004-2006) in 1963 in Fragile and conflict affected situations to that in High income?
Your response must be concise. 0.6. What is the ratio of the Production index(2004-2006) of 1964 in Fragile and conflict affected situations to that in High income?
Your answer should be very brief. 0.62. What is the ratio of the Production index(2004-2006) of 1961 in Fragile and conflict affected situations to that in High income: nonOECD?
Your answer should be very brief. 0.86. What is the ratio of the Production index(2004-2006) of 1962 in Fragile and conflict affected situations to that in High income: nonOECD?
Provide a succinct answer. 0.88. What is the ratio of the Production index(2004-2006) in 1963 in Fragile and conflict affected situations to that in High income: nonOECD?
Provide a short and direct response. 0.82. What is the ratio of the Production index(2004-2006) in 1964 in Fragile and conflict affected situations to that in High income: nonOECD?
Offer a very short reply. 0.88. What is the ratio of the Production index(2004-2006) in 1961 in Fragile and conflict affected situations to that in High income: OECD?
Your answer should be very brief. 0.58. What is the ratio of the Production index(2004-2006) in 1962 in Fragile and conflict affected situations to that in High income: OECD?
Your answer should be compact. 0.6. What is the ratio of the Production index(2004-2006) of 1963 in Fragile and conflict affected situations to that in High income: OECD?
Give a very brief answer. 0.58. What is the ratio of the Production index(2004-2006) of 1964 in Fragile and conflict affected situations to that in High income: OECD?
Your response must be concise. 0.6. What is the ratio of the Production index(2004-2006) in 1961 in Fragile and conflict affected situations to that in Latin America(all income levels)?
Keep it short and to the point. 1.24. What is the ratio of the Production index(2004-2006) in 1962 in Fragile and conflict affected situations to that in Latin America(all income levels)?
Provide a succinct answer. 1.28. What is the ratio of the Production index(2004-2006) of 1963 in Fragile and conflict affected situations to that in Latin America(all income levels)?
Your response must be concise. 1.24. What is the ratio of the Production index(2004-2006) of 1964 in Fragile and conflict affected situations to that in Latin America(all income levels)?
Your response must be concise. 1.25. What is the ratio of the Production index(2004-2006) of 1961 in Heavily indebted poor countries to that in High income?
Make the answer very short. 0.65. What is the ratio of the Production index(2004-2006) in 1962 in Heavily indebted poor countries to that in High income?
Your answer should be very brief. 0.65. What is the ratio of the Production index(2004-2006) of 1963 in Heavily indebted poor countries to that in High income?
Ensure brevity in your answer.  0.64. What is the ratio of the Production index(2004-2006) in 1964 in Heavily indebted poor countries to that in High income?
Your answer should be compact. 0.66. What is the ratio of the Production index(2004-2006) in 1961 in Heavily indebted poor countries to that in High income: nonOECD?
Make the answer very short. 0.94. What is the ratio of the Production index(2004-2006) of 1962 in Heavily indebted poor countries to that in High income: nonOECD?
Offer a terse response. 0.93. What is the ratio of the Production index(2004-2006) in 1963 in Heavily indebted poor countries to that in High income: nonOECD?
Give a very brief answer. 0.88. What is the ratio of the Production index(2004-2006) of 1964 in Heavily indebted poor countries to that in High income: nonOECD?
Provide a short and direct response. 0.93. What is the ratio of the Production index(2004-2006) of 1961 in Heavily indebted poor countries to that in High income: OECD?
Your answer should be very brief. 0.63. What is the ratio of the Production index(2004-2006) of 1962 in Heavily indebted poor countries to that in High income: OECD?
Your answer should be compact. 0.63. What is the ratio of the Production index(2004-2006) of 1963 in Heavily indebted poor countries to that in High income: OECD?
Your answer should be very brief. 0.62. What is the ratio of the Production index(2004-2006) in 1964 in Heavily indebted poor countries to that in High income: OECD?
Provide a succinct answer. 0.64. What is the ratio of the Production index(2004-2006) of 1961 in Heavily indebted poor countries to that in Latin America(all income levels)?
Your answer should be very brief. 1.35. What is the ratio of the Production index(2004-2006) in 1962 in Heavily indebted poor countries to that in Latin America(all income levels)?
Provide a short and direct response. 1.34. What is the ratio of the Production index(2004-2006) in 1963 in Heavily indebted poor countries to that in Latin America(all income levels)?
Your response must be concise. 1.33. What is the ratio of the Production index(2004-2006) in 1964 in Heavily indebted poor countries to that in Latin America(all income levels)?
Offer a terse response. 1.33. What is the ratio of the Production index(2004-2006) in 1961 in High income to that in High income: nonOECD?
Make the answer very short. 1.44. What is the ratio of the Production index(2004-2006) in 1962 in High income to that in High income: nonOECD?
Your answer should be compact. 1.43. What is the ratio of the Production index(2004-2006) in 1963 in High income to that in High income: nonOECD?
Make the answer very short. 1.37. What is the ratio of the Production index(2004-2006) in 1964 in High income to that in High income: nonOECD?
Your answer should be compact. 1.42. What is the ratio of the Production index(2004-2006) in 1962 in High income to that in High income: OECD?
Give a very brief answer. 0.97. What is the ratio of the Production index(2004-2006) in 1963 in High income to that in High income: OECD?
Keep it short and to the point. 0.97. What is the ratio of the Production index(2004-2006) in 1964 in High income to that in High income: OECD?
Ensure brevity in your answer.  0.97. What is the ratio of the Production index(2004-2006) of 1961 in High income to that in Latin America(all income levels)?
Your response must be concise. 2.07. What is the ratio of the Production index(2004-2006) of 1962 in High income to that in Latin America(all income levels)?
Your answer should be very brief. 2.07. What is the ratio of the Production index(2004-2006) of 1963 in High income to that in Latin America(all income levels)?
Offer a terse response. 2.07. What is the ratio of the Production index(2004-2006) of 1964 in High income to that in Latin America(all income levels)?
Give a very brief answer. 2.02. What is the ratio of the Production index(2004-2006) of 1961 in High income: nonOECD to that in High income: OECD?
Give a very brief answer. 0.67. What is the ratio of the Production index(2004-2006) of 1962 in High income: nonOECD to that in High income: OECD?
Provide a short and direct response. 0.68. What is the ratio of the Production index(2004-2006) of 1963 in High income: nonOECD to that in High income: OECD?
Ensure brevity in your answer.  0.71. What is the ratio of the Production index(2004-2006) in 1964 in High income: nonOECD to that in High income: OECD?
Keep it short and to the point. 0.68. What is the ratio of the Production index(2004-2006) in 1961 in High income: nonOECD to that in Latin America(all income levels)?
Provide a short and direct response. 1.43. What is the ratio of the Production index(2004-2006) of 1962 in High income: nonOECD to that in Latin America(all income levels)?
Provide a short and direct response. 1.45. What is the ratio of the Production index(2004-2006) of 1963 in High income: nonOECD to that in Latin America(all income levels)?
Offer a terse response. 1.51. What is the ratio of the Production index(2004-2006) of 1964 in High income: nonOECD to that in Latin America(all income levels)?
Make the answer very short. 1.42. What is the ratio of the Production index(2004-2006) of 1961 in High income: OECD to that in Latin America(all income levels)?
Give a very brief answer. 2.14. What is the ratio of the Production index(2004-2006) of 1962 in High income: OECD to that in Latin America(all income levels)?
Ensure brevity in your answer.  2.14. What is the ratio of the Production index(2004-2006) in 1963 in High income: OECD to that in Latin America(all income levels)?
Your answer should be compact. 2.13. What is the ratio of the Production index(2004-2006) of 1964 in High income: OECD to that in Latin America(all income levels)?
Ensure brevity in your answer.  2.09. What is the difference between the highest and the second highest Production index(2004-2006) in 1961?
Offer a terse response. 1.75. What is the difference between the highest and the second highest Production index(2004-2006) of 1962?
Your response must be concise. 1.76. What is the difference between the highest and the second highest Production index(2004-2006) in 1963?
Make the answer very short. 1.66. What is the difference between the highest and the second highest Production index(2004-2006) of 1964?
Your answer should be very brief. 1.82. What is the difference between the highest and the lowest Production index(2004-2006) of 1961?
Make the answer very short. 28.2. What is the difference between the highest and the lowest Production index(2004-2006) of 1962?
Offer a very short reply. 29.24. What is the difference between the highest and the lowest Production index(2004-2006) of 1963?
Ensure brevity in your answer.  30.1. What is the difference between the highest and the lowest Production index(2004-2006) in 1964?
Give a very brief answer. 29.86. 